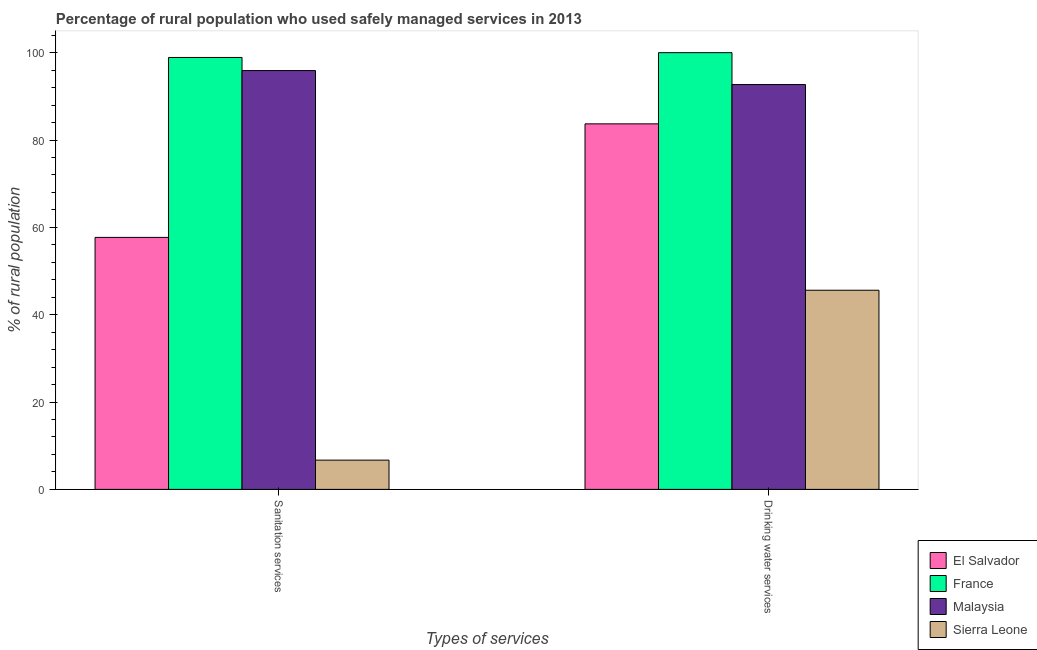Are the number of bars per tick equal to the number of legend labels?
Your answer should be very brief. Yes. How many bars are there on the 2nd tick from the left?
Offer a very short reply. 4. What is the label of the 1st group of bars from the left?
Provide a short and direct response. Sanitation services. What is the percentage of rural population who used sanitation services in Malaysia?
Your answer should be very brief. 95.9. Across all countries, what is the maximum percentage of rural population who used drinking water services?
Ensure brevity in your answer.  100. Across all countries, what is the minimum percentage of rural population who used drinking water services?
Offer a very short reply. 45.6. In which country was the percentage of rural population who used drinking water services maximum?
Your answer should be very brief. France. In which country was the percentage of rural population who used drinking water services minimum?
Offer a terse response. Sierra Leone. What is the total percentage of rural population who used drinking water services in the graph?
Your response must be concise. 322. What is the difference between the percentage of rural population who used drinking water services in Malaysia and that in El Salvador?
Your answer should be very brief. 9. What is the difference between the percentage of rural population who used drinking water services in El Salvador and the percentage of rural population who used sanitation services in Malaysia?
Make the answer very short. -12.2. What is the average percentage of rural population who used drinking water services per country?
Keep it short and to the point. 80.5. What is the difference between the percentage of rural population who used sanitation services and percentage of rural population who used drinking water services in Sierra Leone?
Offer a terse response. -38.9. What is the ratio of the percentage of rural population who used sanitation services in Malaysia to that in Sierra Leone?
Offer a terse response. 14.31. In how many countries, is the percentage of rural population who used drinking water services greater than the average percentage of rural population who used drinking water services taken over all countries?
Your answer should be compact. 3. What does the 4th bar from the right in Sanitation services represents?
Keep it short and to the point. El Salvador. Are all the bars in the graph horizontal?
Your answer should be compact. No. How many countries are there in the graph?
Give a very brief answer. 4. Does the graph contain any zero values?
Provide a succinct answer. No. How many legend labels are there?
Offer a terse response. 4. How are the legend labels stacked?
Your response must be concise. Vertical. What is the title of the graph?
Make the answer very short. Percentage of rural population who used safely managed services in 2013. What is the label or title of the X-axis?
Offer a very short reply. Types of services. What is the label or title of the Y-axis?
Offer a very short reply. % of rural population. What is the % of rural population in El Salvador in Sanitation services?
Offer a very short reply. 57.7. What is the % of rural population of France in Sanitation services?
Provide a short and direct response. 98.9. What is the % of rural population in Malaysia in Sanitation services?
Your answer should be very brief. 95.9. What is the % of rural population in El Salvador in Drinking water services?
Your answer should be compact. 83.7. What is the % of rural population of Malaysia in Drinking water services?
Your answer should be very brief. 92.7. What is the % of rural population of Sierra Leone in Drinking water services?
Give a very brief answer. 45.6. Across all Types of services, what is the maximum % of rural population of El Salvador?
Your response must be concise. 83.7. Across all Types of services, what is the maximum % of rural population of France?
Provide a succinct answer. 100. Across all Types of services, what is the maximum % of rural population of Malaysia?
Offer a very short reply. 95.9. Across all Types of services, what is the maximum % of rural population of Sierra Leone?
Provide a succinct answer. 45.6. Across all Types of services, what is the minimum % of rural population in El Salvador?
Give a very brief answer. 57.7. Across all Types of services, what is the minimum % of rural population of France?
Ensure brevity in your answer.  98.9. Across all Types of services, what is the minimum % of rural population in Malaysia?
Ensure brevity in your answer.  92.7. What is the total % of rural population of El Salvador in the graph?
Offer a terse response. 141.4. What is the total % of rural population of France in the graph?
Your response must be concise. 198.9. What is the total % of rural population of Malaysia in the graph?
Make the answer very short. 188.6. What is the total % of rural population of Sierra Leone in the graph?
Offer a very short reply. 52.3. What is the difference between the % of rural population in Sierra Leone in Sanitation services and that in Drinking water services?
Provide a short and direct response. -38.9. What is the difference between the % of rural population in El Salvador in Sanitation services and the % of rural population in France in Drinking water services?
Give a very brief answer. -42.3. What is the difference between the % of rural population of El Salvador in Sanitation services and the % of rural population of Malaysia in Drinking water services?
Provide a succinct answer. -35. What is the difference between the % of rural population in France in Sanitation services and the % of rural population in Malaysia in Drinking water services?
Provide a succinct answer. 6.2. What is the difference between the % of rural population in France in Sanitation services and the % of rural population in Sierra Leone in Drinking water services?
Your answer should be very brief. 53.3. What is the difference between the % of rural population of Malaysia in Sanitation services and the % of rural population of Sierra Leone in Drinking water services?
Provide a succinct answer. 50.3. What is the average % of rural population of El Salvador per Types of services?
Make the answer very short. 70.7. What is the average % of rural population in France per Types of services?
Provide a short and direct response. 99.45. What is the average % of rural population of Malaysia per Types of services?
Provide a succinct answer. 94.3. What is the average % of rural population in Sierra Leone per Types of services?
Provide a succinct answer. 26.15. What is the difference between the % of rural population of El Salvador and % of rural population of France in Sanitation services?
Make the answer very short. -41.2. What is the difference between the % of rural population in El Salvador and % of rural population in Malaysia in Sanitation services?
Offer a very short reply. -38.2. What is the difference between the % of rural population in El Salvador and % of rural population in Sierra Leone in Sanitation services?
Keep it short and to the point. 51. What is the difference between the % of rural population in France and % of rural population in Malaysia in Sanitation services?
Your response must be concise. 3. What is the difference between the % of rural population of France and % of rural population of Sierra Leone in Sanitation services?
Give a very brief answer. 92.2. What is the difference between the % of rural population in Malaysia and % of rural population in Sierra Leone in Sanitation services?
Your response must be concise. 89.2. What is the difference between the % of rural population in El Salvador and % of rural population in France in Drinking water services?
Provide a short and direct response. -16.3. What is the difference between the % of rural population in El Salvador and % of rural population in Sierra Leone in Drinking water services?
Make the answer very short. 38.1. What is the difference between the % of rural population of France and % of rural population of Sierra Leone in Drinking water services?
Offer a terse response. 54.4. What is the difference between the % of rural population in Malaysia and % of rural population in Sierra Leone in Drinking water services?
Offer a terse response. 47.1. What is the ratio of the % of rural population of El Salvador in Sanitation services to that in Drinking water services?
Provide a short and direct response. 0.69. What is the ratio of the % of rural population of France in Sanitation services to that in Drinking water services?
Your answer should be compact. 0.99. What is the ratio of the % of rural population of Malaysia in Sanitation services to that in Drinking water services?
Your answer should be compact. 1.03. What is the ratio of the % of rural population of Sierra Leone in Sanitation services to that in Drinking water services?
Provide a succinct answer. 0.15. What is the difference between the highest and the second highest % of rural population in Sierra Leone?
Provide a short and direct response. 38.9. What is the difference between the highest and the lowest % of rural population in El Salvador?
Offer a very short reply. 26. What is the difference between the highest and the lowest % of rural population in Sierra Leone?
Keep it short and to the point. 38.9. 